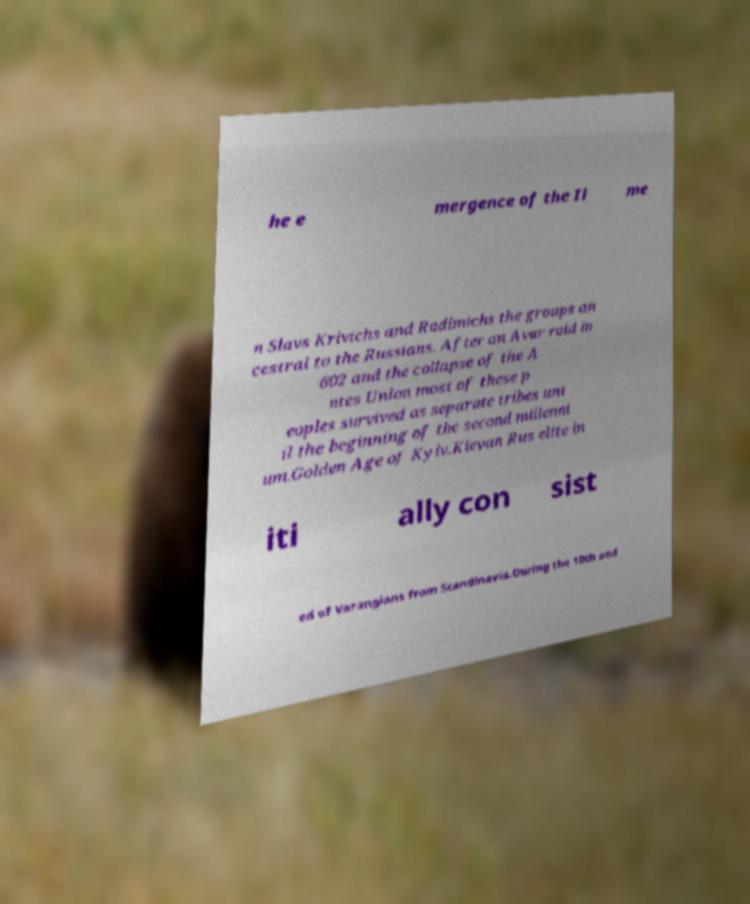For documentation purposes, I need the text within this image transcribed. Could you provide that? he e mergence of the Il me n Slavs Krivichs and Radimichs the groups an cestral to the Russians. After an Avar raid in 602 and the collapse of the A ntes Union most of these p eoples survived as separate tribes unt il the beginning of the second millenni um.Golden Age of Kyiv.Kievan Rus elite in iti ally con sist ed of Varangians from Scandinavia.During the 10th and 